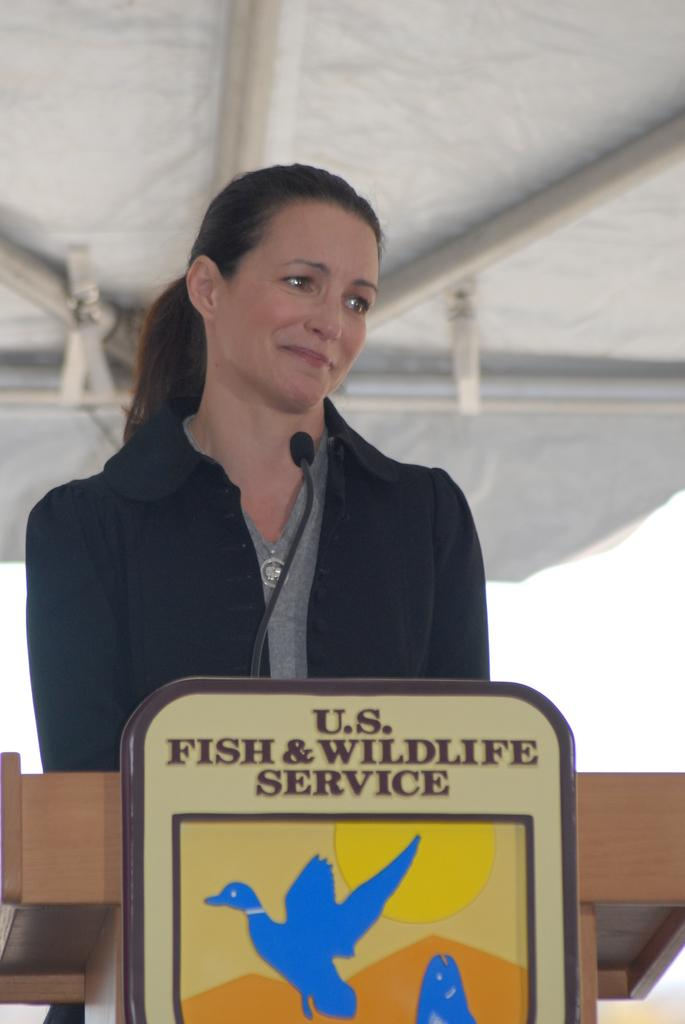<image>
Present a compact description of the photo's key features. woman talking at podium for the u.s. fish & wildlife service 